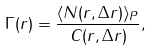Convert formula to latex. <formula><loc_0><loc_0><loc_500><loc_500>\Gamma ( r ) = \frac { \langle { N ( r , \Delta { r } ) } \rangle _ { P } } { \| C ( r , \Delta { r } ) \| } ,</formula> 